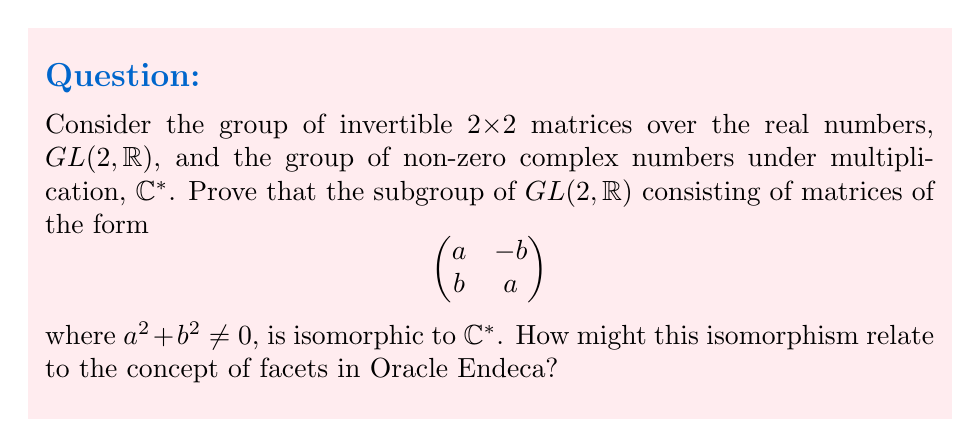Solve this math problem. Let's approach this step-by-step:

1) First, let's define a mapping $f$ from our subgroup of $GL(2, \mathbb{R})$ to $\mathbb{C}^*$:

   $f: \begin{pmatrix} 
   a & -b \\ 
   b & a 
   \end{pmatrix} \mapsto a + bi$

2) We need to prove that $f$ is a homomorphism:
   Let $A = \begin{pmatrix} 
   a & -b \\ 
   b & a 
   \end{pmatrix}$ and $B = \begin{pmatrix} 
   c & -d \\ 
   d & c 
   \end{pmatrix}$

   $f(AB) = f(\begin{pmatrix} 
   ac-bd & -(ad+bc) \\ 
   ad+bc & ac-bd 
   \end{pmatrix}) = (ac-bd) + (ad+bc)i$

   $f(A)f(B) = (a+bi)(c+di) = (ac-bd) + (ad+bc)i$

   Thus, $f(AB) = f(A)f(B)$, so $f$ is a homomorphism.

3) To prove $f$ is injective, suppose $f(A) = f(B)$. This means $a+bi = c+di$, which implies $a=c$ and $b=d$, so $A=B$.

4) To prove $f$ is surjective, for any $z = x+yi \in \mathbb{C}^*$, we can find $A = \begin{pmatrix} 
   x & -y \\ 
   y & x 
   \end{pmatrix}$ in our subgroup such that $f(A) = z$.

5) Therefore, $f$ is bijective and a homomorphism, thus an isomorphism.

Relating to Oracle Endeca:
In Oracle Endeca, facets are used to categorize and filter data. This isomorphism demonstrates a one-to-one correspondence between two different representations of the same structure, similar to how facets in Endeca provide different views or categorizations of the same underlying data. Just as this isomorphism allows us to switch between matrix and complex number representations seamlessly, Endeca's faceted navigation allows users to switch between different views of data without losing the underlying structure or relationships.
Answer: The subgroup is isomorphic to $\mathbb{C}^*$ via $f(\begin{pmatrix} 
a & -b \\ 
b & a 
\end{pmatrix}) = a + bi$ 